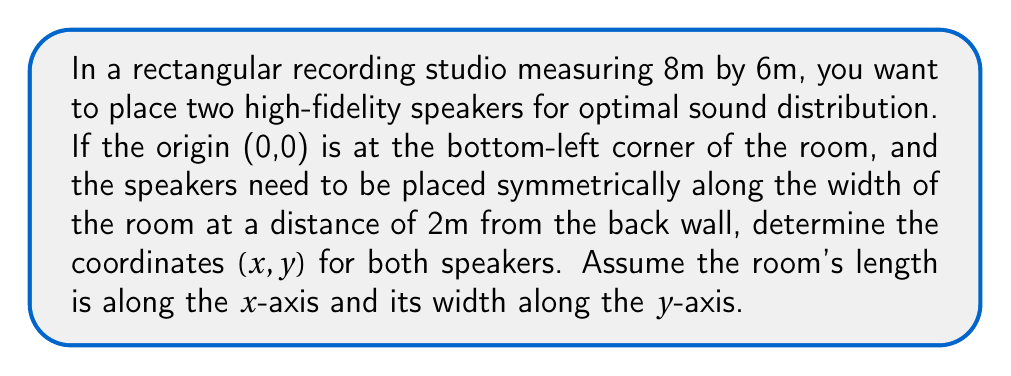What is the answer to this math problem? Let's approach this step-by-step:

1) First, we need to understand the room's dimensions in the coordinate system:
   - Length (x-axis): 8m
   - Width (y-axis): 6m

2) The speakers need to be 2m from the back wall. Since the room is 8m long, their x-coordinate will be:
   $x = 8 - 2 = 6$

3) For symmetric placement along the width, we need to divide the width into three equal parts:
   $6 \div 3 = 2$

4) So, the speakers will be placed 2m from each side wall. Their y-coordinates will be:
   - Speaker 1: $y_1 = 2$
   - Speaker 2: $y_2 = 6 - 2 = 4$

5) Therefore, the coordinates for the two speakers are:
   - Speaker 1: (6, 2)
   - Speaker 2: (6, 4)

To visualize:

[asy]
unitsize(1cm);
draw((0,0)--(8,0)--(8,6)--(0,6)--cycle);
dot((6,2));
dot((6,4));
label("(6,2)", (6,2), SW);
label("(6,4)", (6,4), NW);
label("8m", (4,0), S);
label("6m", (0,3), W);
[/asy]
Answer: Speaker 1: (6, 2), Speaker 2: (6, 4) 